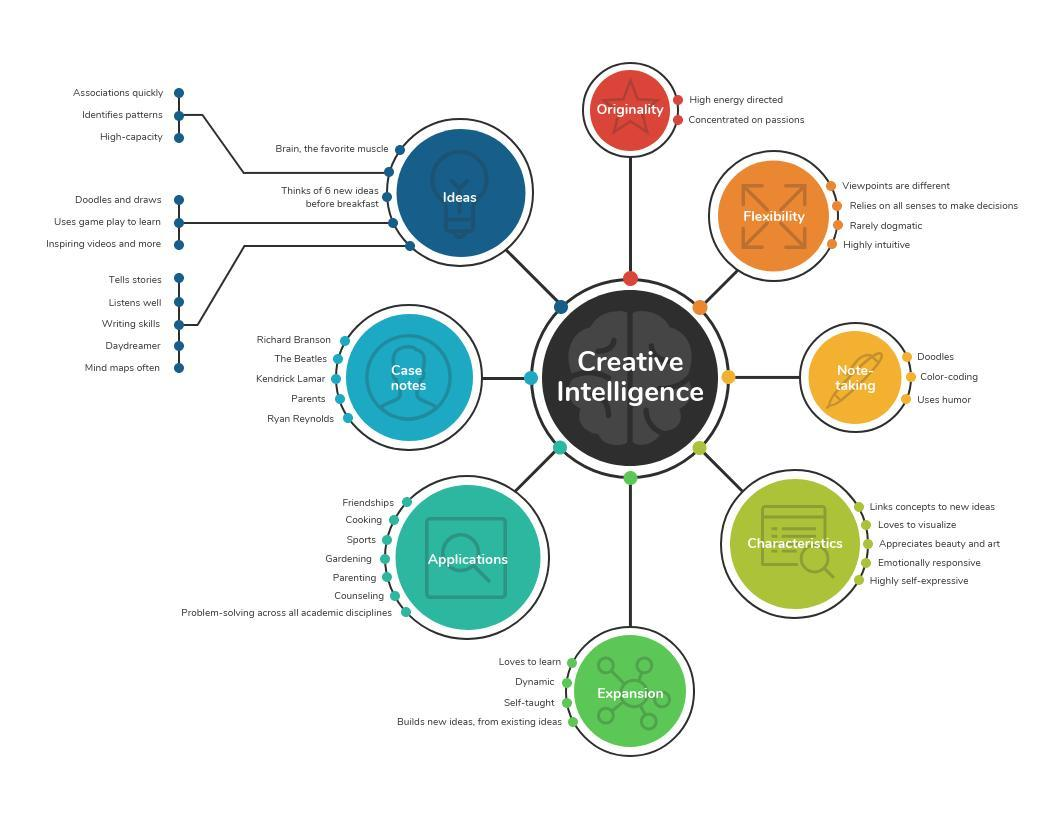What is written inside the yellow circle?
Answer the question with a short phrase. Note-taking What colour is the circle in which Originality is written- red, blue or green? Red 